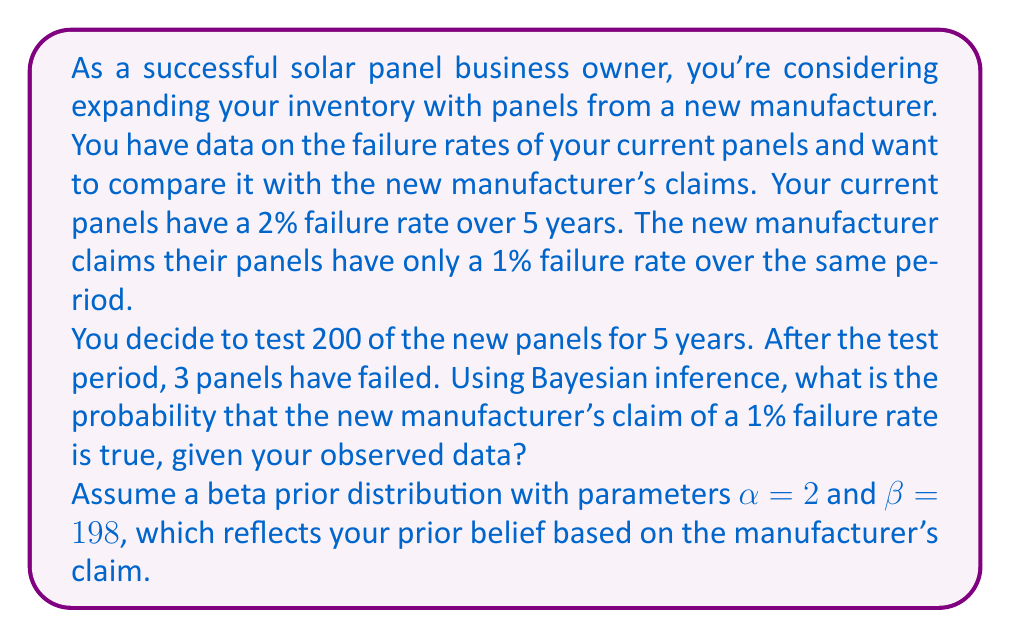Give your solution to this math problem. Let's approach this step-by-step using Bayesian inference:

1) Our prior belief is represented by a Beta(2, 198) distribution, which has a mean of 1%, matching the manufacturer's claim.

2) We observe 3 failures out of 200 panels over 5 years.

3) The likelihood of observing 3 failures out of 200 trials, given a true failure rate of θ, follows a Binomial distribution:

   $P(X=3|θ) = \binom{200}{3}θ^3(1-θ)^{197}$

4) The posterior distribution is proportional to the product of the prior and the likelihood:

   $P(θ|X=3) \propto \text{Beta}(2,198) \times \text{Binomial}(200,3,θ)$

5) The resulting posterior distribution is Beta(5, 395), as we add the number of successes and failures to the prior parameters.

6) To find the probability that the true failure rate is 1% or less, we need to calculate the cumulative distribution function (CDF) of the Beta(5, 395) distribution at θ = 0.01:

   $P(θ \leq 0.01|X=3) = \int_0^{0.01} \frac{θ^{4}(1-θ)^{394}}{B(5,395)} dθ$

   where B(5,395) is the beta function.

7) This integral doesn't have a simple closed form, so we typically use numerical methods or statistical software to evaluate it.

8) Using a statistical calculator or software, we find:

   $P(θ \leq 0.01|X=3) \approx 0.8413$

Therefore, the probability that the new manufacturer's claim of a 1% failure rate is true (or better), given your observed data, is approximately 0.8413 or 84.13%.
Answer: 0.8413 